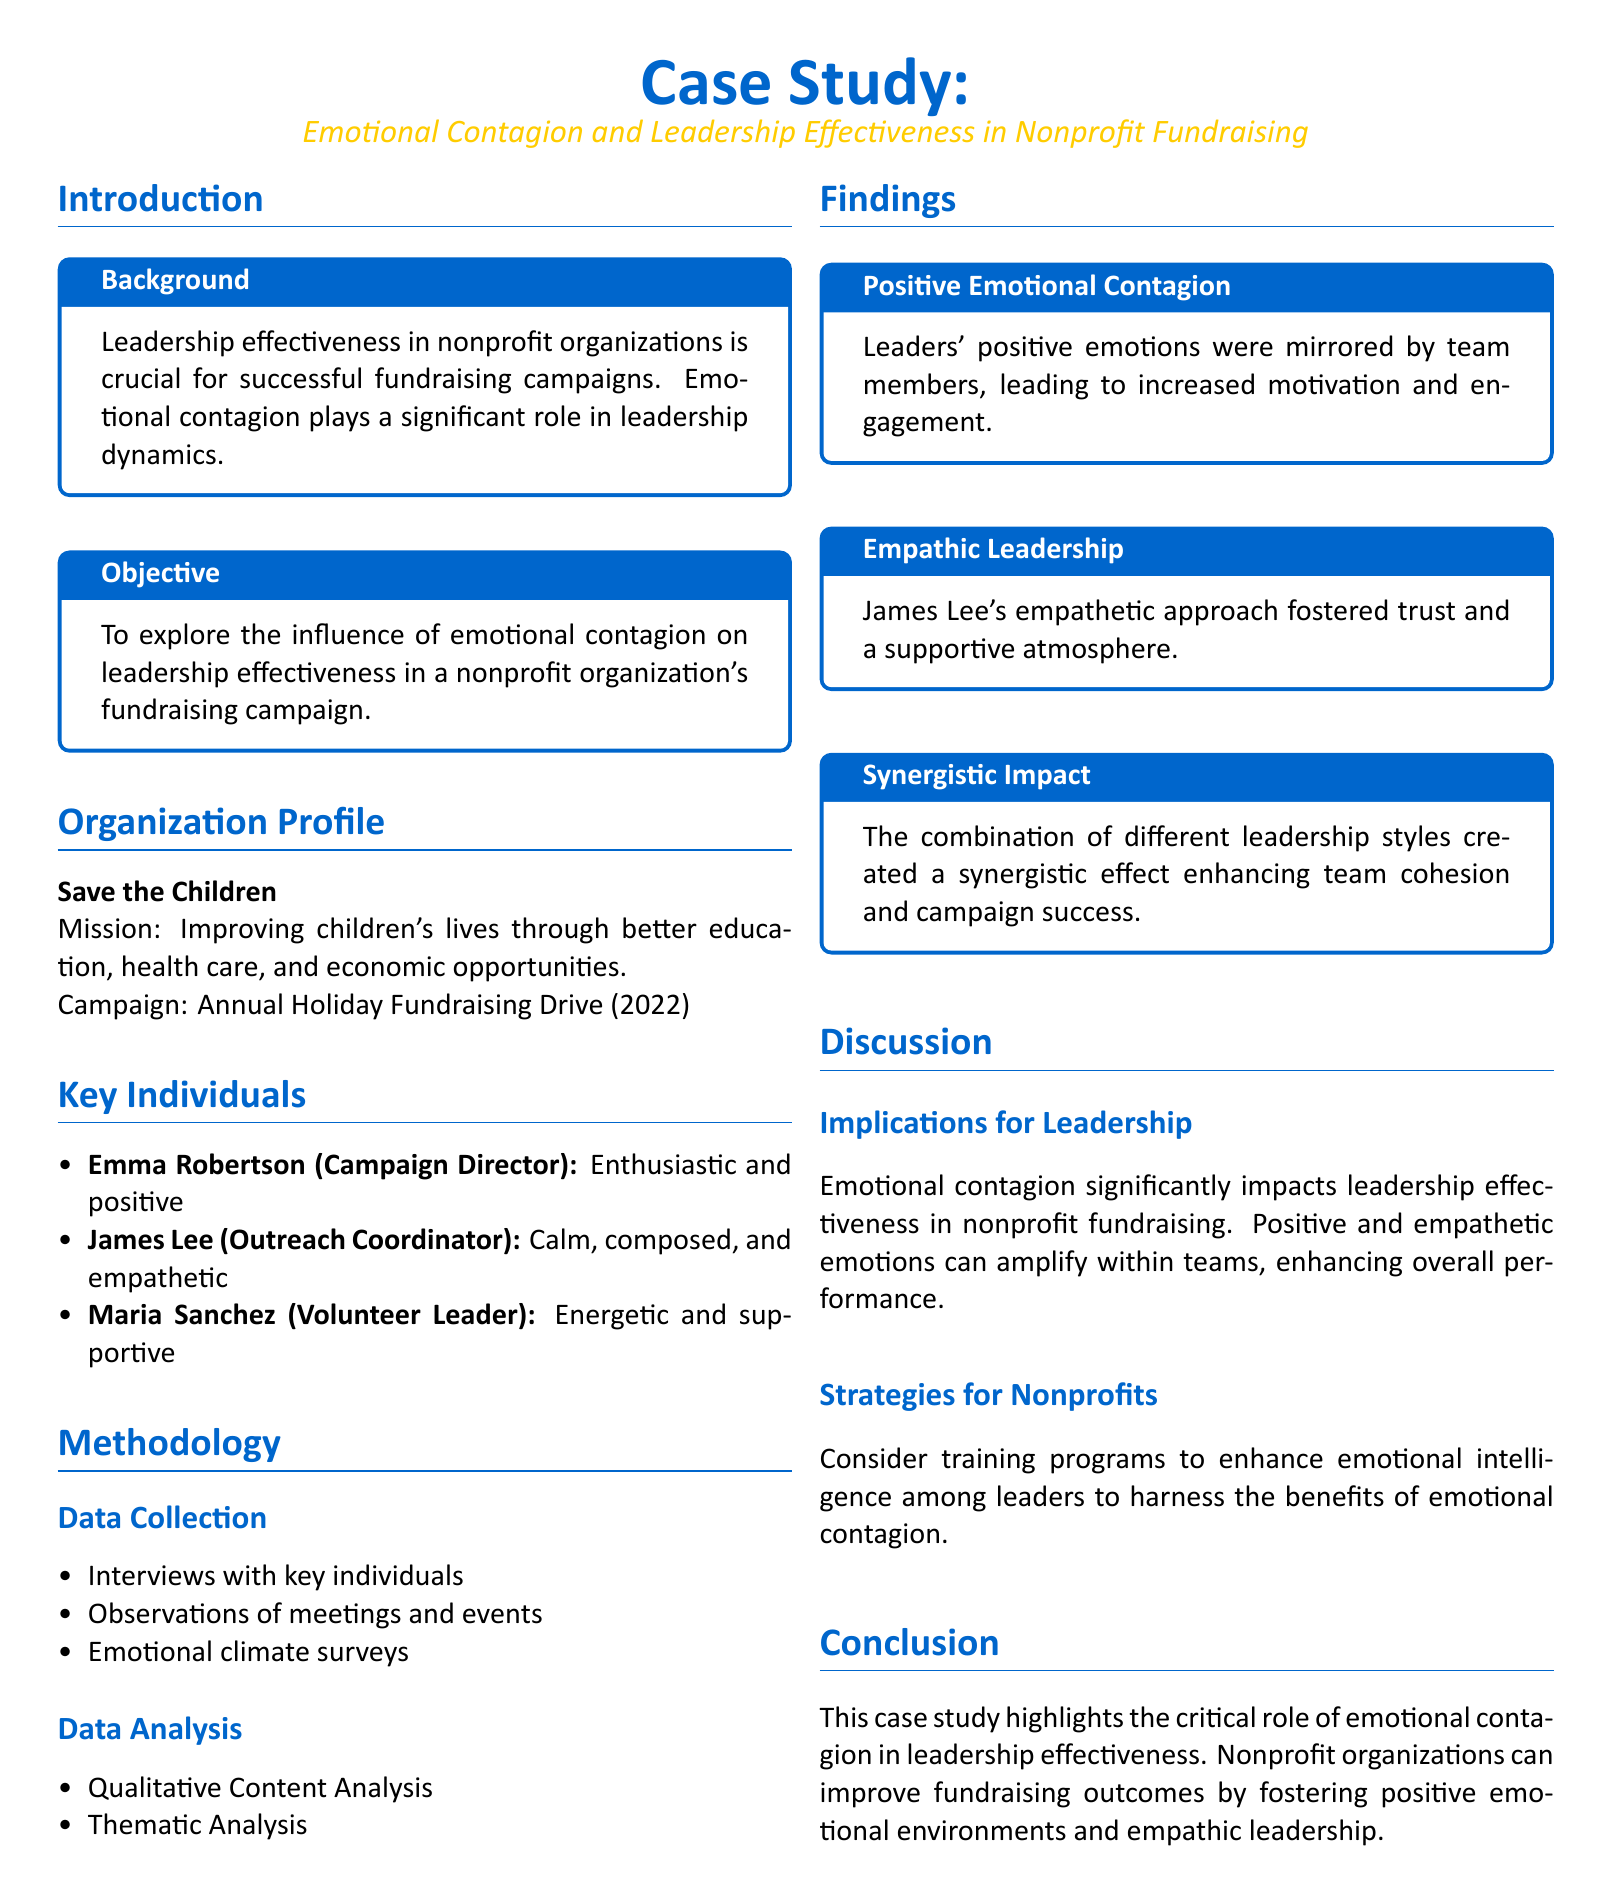What is the mission of Save the Children? The mission is to improve children's lives through better education, health care, and economic opportunities.
Answer: Improving children's lives through better education, health care, and economic opportunities Who is the Campaign Director mentioned in the case study? The case study names Emma Robertson as the Campaign Director.
Answer: Emma Robertson What leadership style is associated with James Lee? James Lee is described as calm, composed, and empathetic.
Answer: Empathetic What was the campaign conducted by Save the Children in 2022? The campaign is referred to as the Annual Holiday Fundraising Drive.
Answer: Annual Holiday Fundraising Drive (2022) How many key individuals are identified in the study? The text lists three key individuals in the organization.
Answer: Three What type of analysis was performed on the gathered data? The methodology included Qualitative Content Analysis and Thematic Analysis.
Answer: Qualitative Content Analysis, Thematic Analysis What impact does positive emotional contagion have according to the findings? Positive emotional contagion leads to increased motivation and engagement.
Answer: Increased motivation and engagement What does the case study suggest for nonprofits to improve leadership? It suggests implementing training programs to enhance emotional intelligence among leaders.
Answer: Training programs to enhance emotional intelligence 